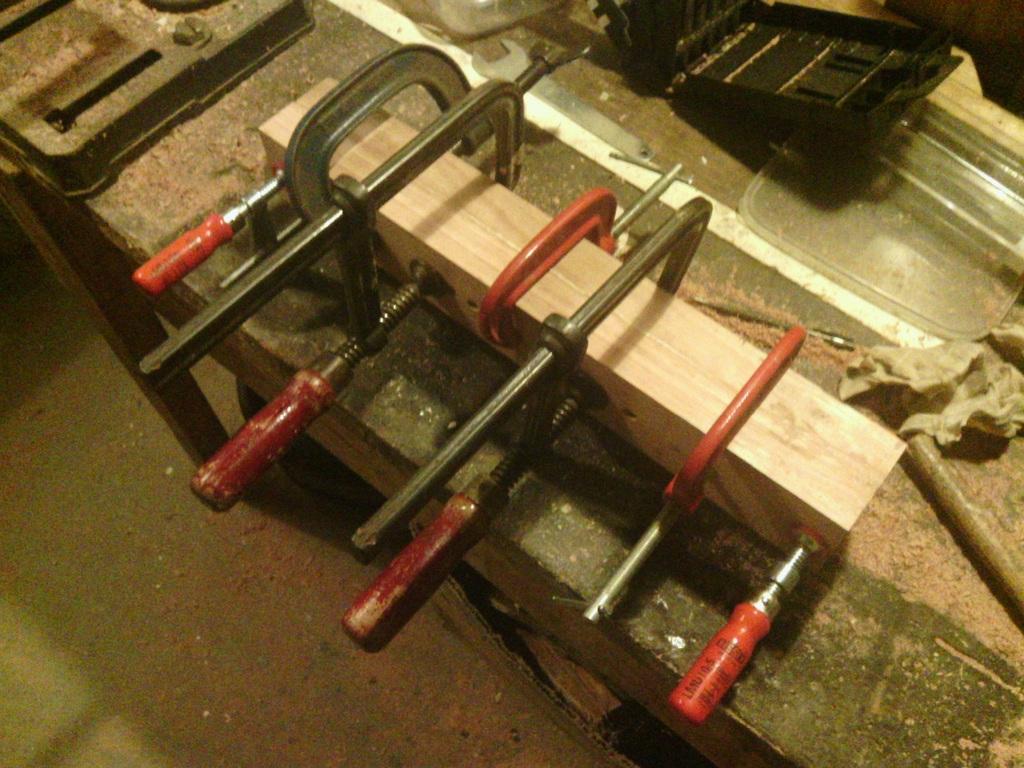Can you describe this image briefly? In this image we can see tools on the table and saw dust. 